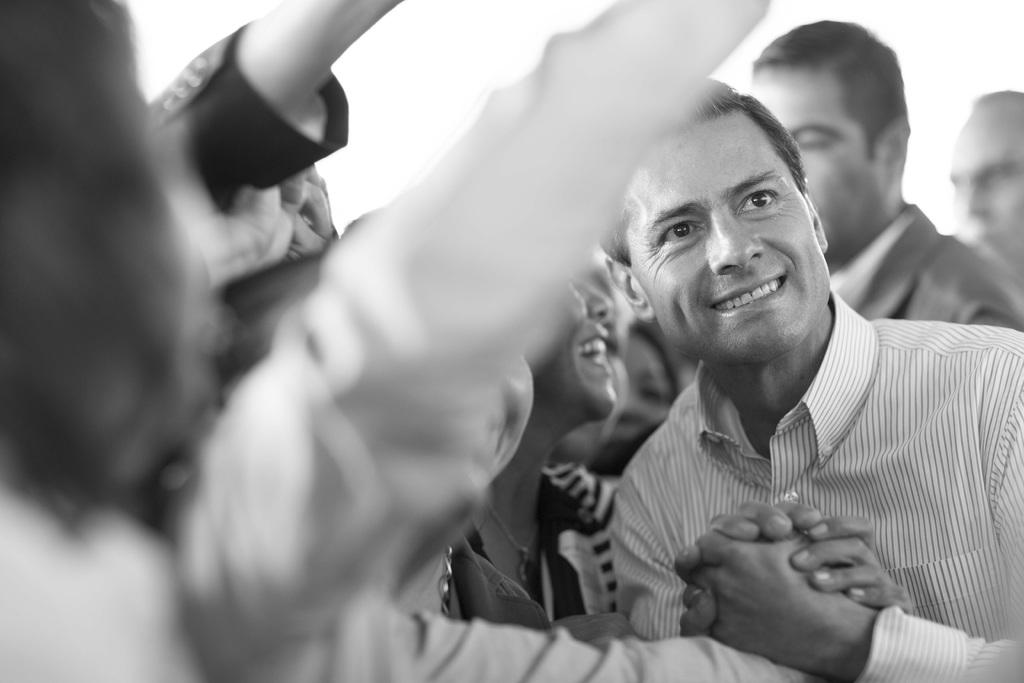What is the color scheme of the image? The image is black and white. What can be seen in the image? There are people in the image. How are the people in the image feeling or expressing themselves? The people are smiling in the image. What might the people be doing in the image? It appears that the people are taking a selfie. What is the income of the people in the image? There is no information about the income of the people in the image. Can you see a wheel or cart in the image? There is no wheel or cart present in the image. 